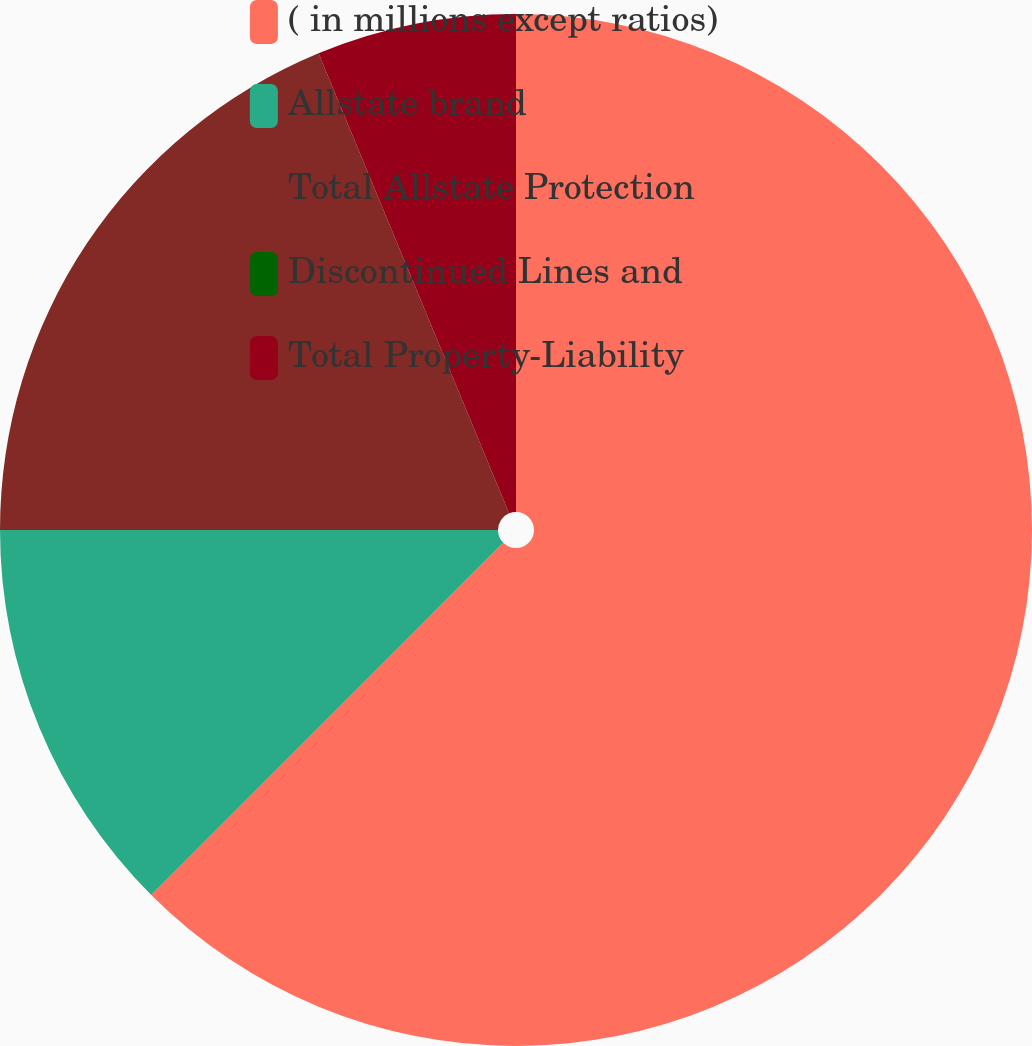<chart> <loc_0><loc_0><loc_500><loc_500><pie_chart><fcel>( in millions except ratios)<fcel>Allstate brand<fcel>Total Allstate Protection<fcel>Discontinued Lines and<fcel>Total Property-Liability<nl><fcel>62.49%<fcel>12.5%<fcel>18.75%<fcel>0.0%<fcel>6.25%<nl></chart> 